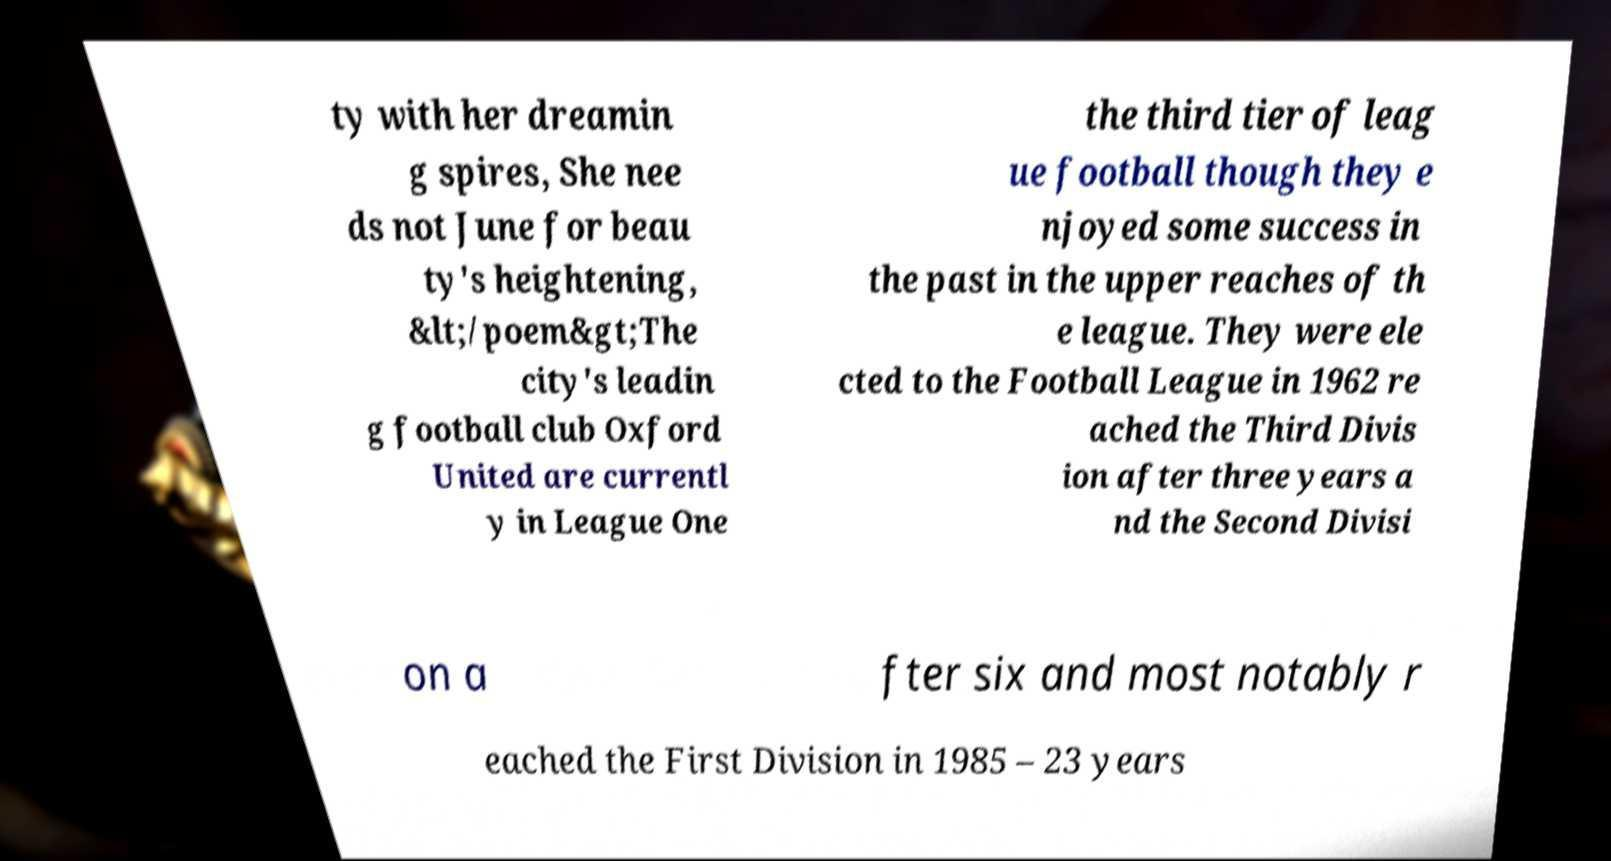For documentation purposes, I need the text within this image transcribed. Could you provide that? ty with her dreamin g spires, She nee ds not June for beau ty's heightening, &lt;/poem&gt;The city's leadin g football club Oxford United are currentl y in League One the third tier of leag ue football though they e njoyed some success in the past in the upper reaches of th e league. They were ele cted to the Football League in 1962 re ached the Third Divis ion after three years a nd the Second Divisi on a fter six and most notably r eached the First Division in 1985 – 23 years 